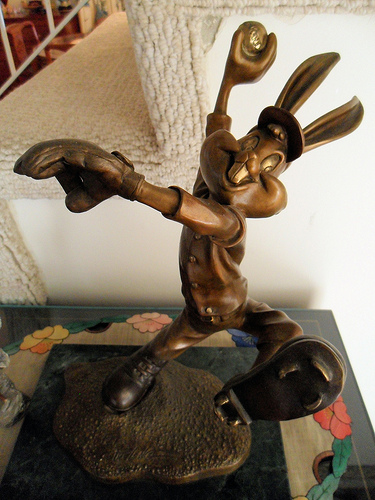<image>
Can you confirm if the statue is next to the wall? No. The statue is not positioned next to the wall. They are located in different areas of the scene. 